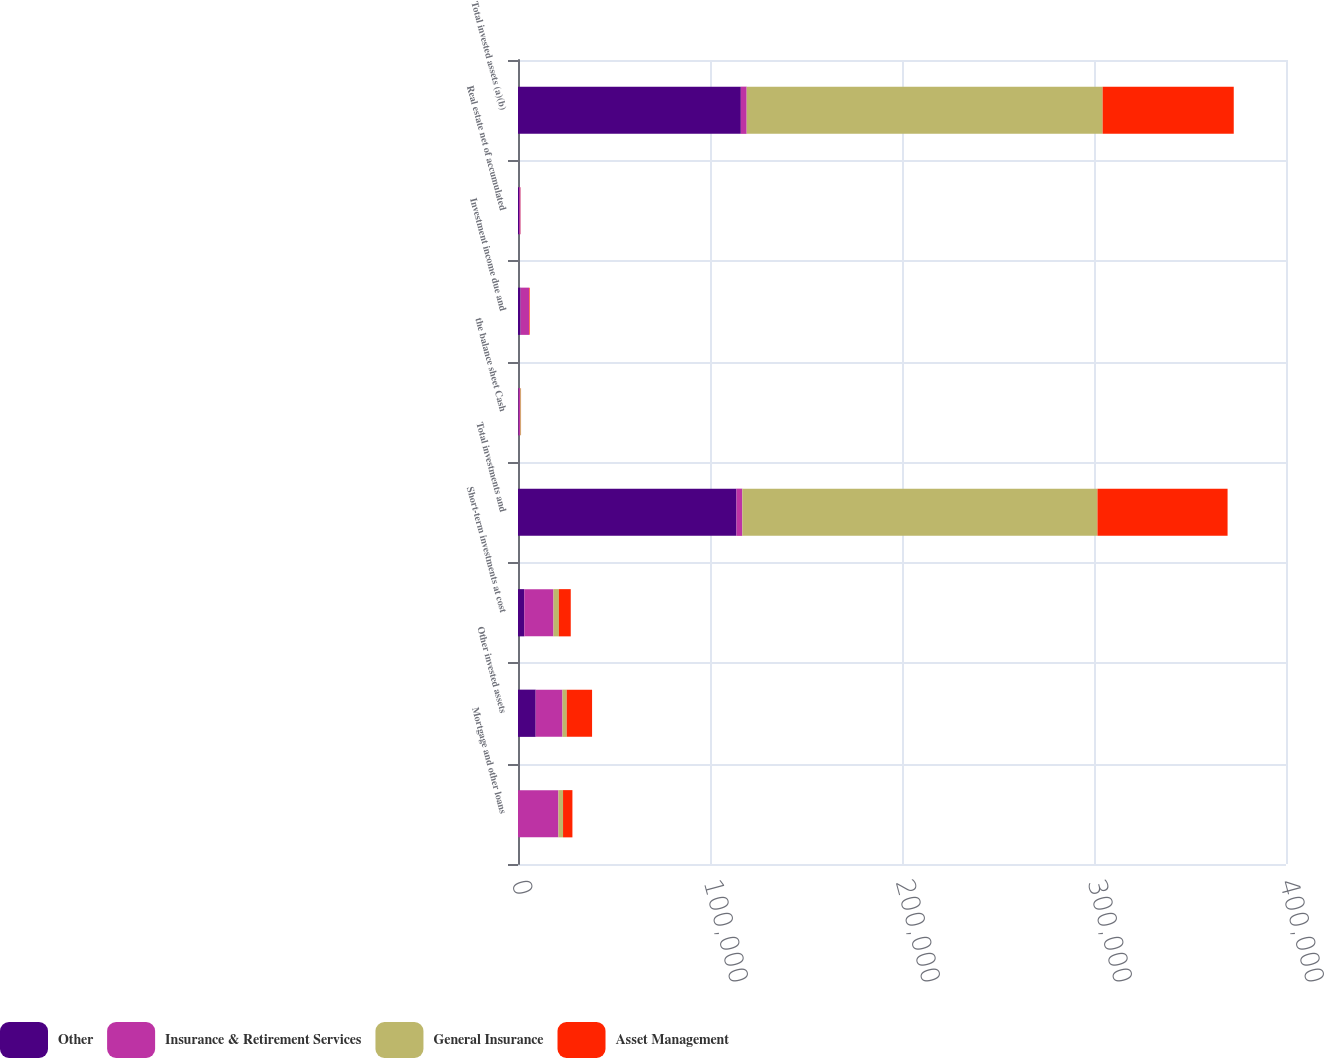<chart> <loc_0><loc_0><loc_500><loc_500><stacked_bar_chart><ecel><fcel>Mortgage and other loans<fcel>Other invested assets<fcel>Short-term investments at cost<fcel>Total investments and<fcel>the balance sheet Cash<fcel>Investment income due and<fcel>Real estate net of accumulated<fcel>Total invested assets (a)(b)<nl><fcel>Other<fcel>17<fcel>9207<fcel>3281<fcel>113792<fcel>334<fcel>1363<fcel>570<fcel>116059<nl><fcel>Insurance & Retirement Services<fcel>21043<fcel>13962<fcel>15192<fcel>3044<fcel>740<fcel>4378<fcel>698<fcel>3044<nl><fcel>General Insurance<fcel>2398<fcel>2212<fcel>2807<fcel>184974<fcel>390<fcel>23<fcel>17<fcel>185404<nl><fcel>Asset Management<fcel>4884<fcel>13198<fcel>6198<fcel>67761<fcel>118<fcel>326<fcel>75<fcel>68280<nl></chart> 